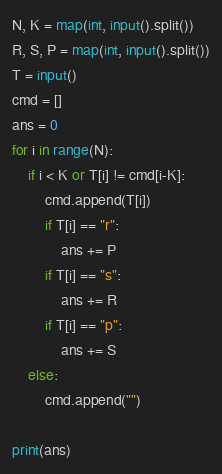Convert code to text. <code><loc_0><loc_0><loc_500><loc_500><_Python_>N, K = map(int, input().split())
R, S, P = map(int, input().split())
T = input()
cmd = []
ans = 0
for i in range(N):
    if i < K or T[i] != cmd[i-K]:
        cmd.append(T[i])
        if T[i] == "r":
            ans += P
        if T[i] == "s":
            ans += R
        if T[i] == "p":
            ans += S
    else:
        cmd.append("")

print(ans)
</code> 